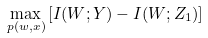Convert formula to latex. <formula><loc_0><loc_0><loc_500><loc_500>\max _ { p ( w , x ) } \left [ I ( W ; Y ) - I ( W ; Z _ { 1 } ) \right ]</formula> 